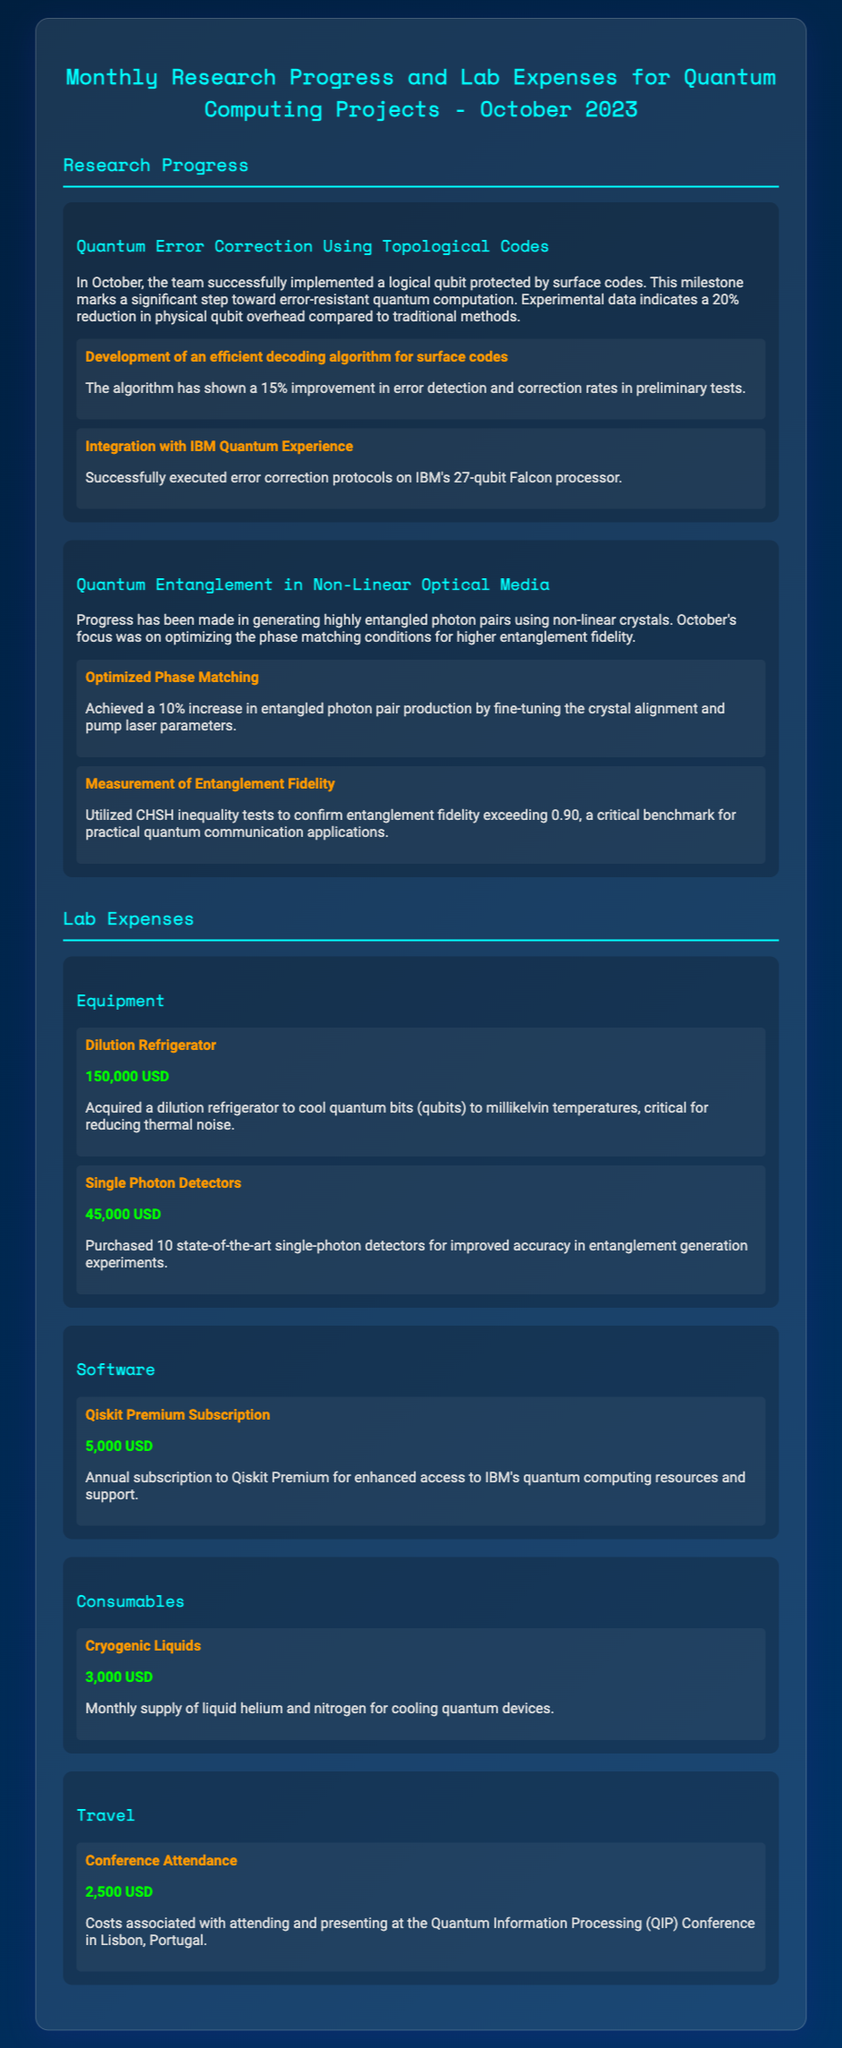What is the focus of the project "Quantum Error Correction Using Topological Codes"? The focus of the project is on implementing a logical qubit protected by surface codes.
Answer: Implementing a logical qubit protected by surface codes What was the cost of the dilution refrigerator? The cost specified for the dilution refrigerator in the lab expenses is given directly in the document.
Answer: 150,000 USD What percentage increase was achieved in entangled photon pair production? This information can be found in the achievement section related to the project's progress.
Answer: 10% What type of subscription was purchased for software? The specific type of software subscription mentioned in the expenditures is detailed in the software expense category.
Answer: Qiskit Premium Subscription What milestone was achieved in the implementation of error correction algorithms? The document states a specific improvement that was made in error detection and correction rates.
Answer: 15% improvement What was the purpose of acquiring cryogenic liquids? The document provides a brief explanation of why cryogenic liquids are required for the lab.
Answer: Cooling quantum devices How much was spent on conference attendance? The amount spent for attending the conference is specifically listed under the travel expenses.
Answer: 2,500 USD What type of experiment was integrated with IBM Quantum Experience? The integration discussed pertains to a specific quantum computing task mentioned in the achievements.
Answer: Error correction protocols 